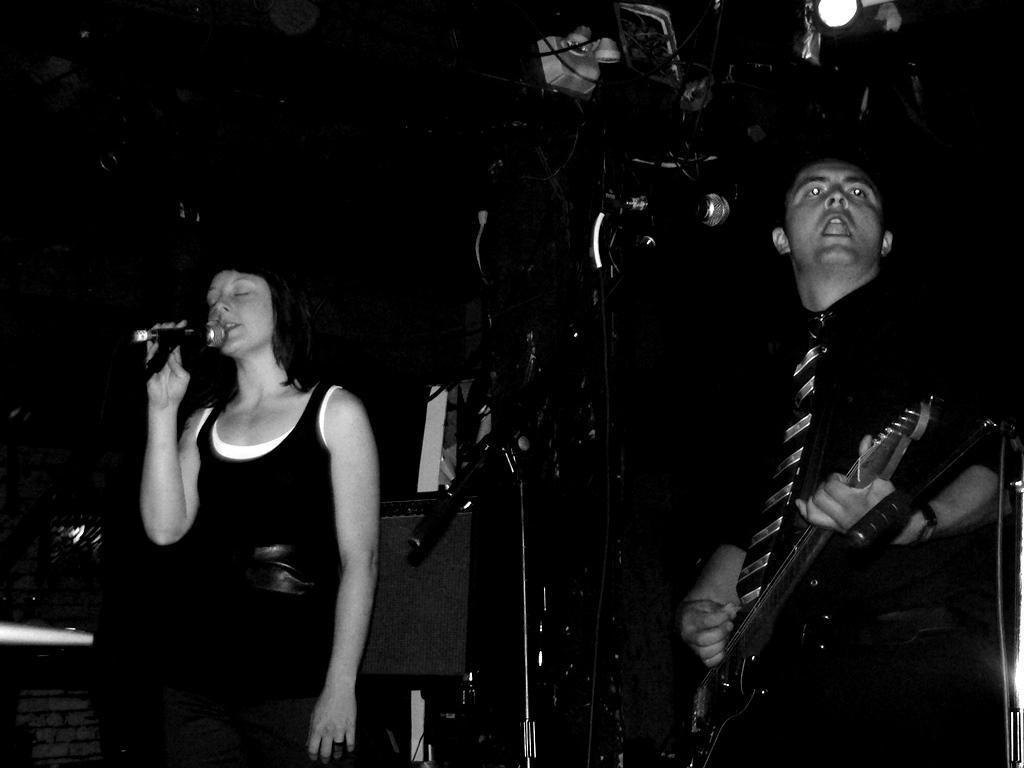Could you give a brief overview of what you see in this image? In the image we can see two persons were standing. The right person he is holding guitar and the left person she is holding microphone. In the background there is a wall,light and few musical instruments. 